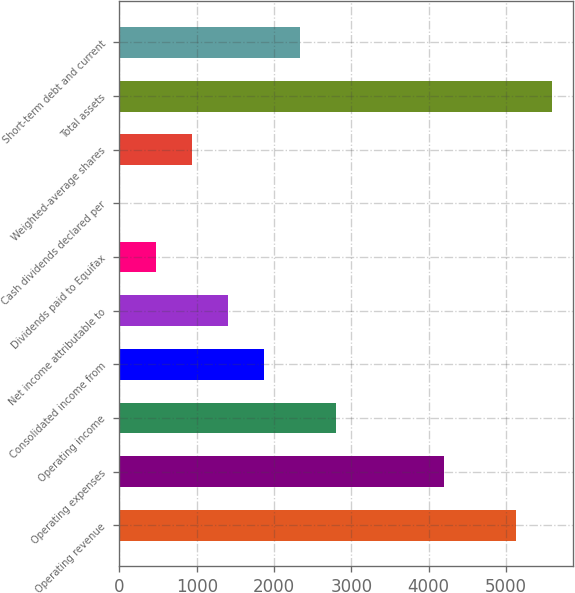Convert chart to OTSL. <chart><loc_0><loc_0><loc_500><loc_500><bar_chart><fcel>Operating revenue<fcel>Operating expenses<fcel>Operating income<fcel>Consolidated income from<fcel>Net income attributable to<fcel>Dividends paid to Equifax<fcel>Cash dividends declared per<fcel>Weighted-average shares<fcel>Total assets<fcel>Short-term debt and current<nl><fcel>5127<fcel>4195<fcel>2797<fcel>1865<fcel>1399<fcel>467<fcel>1<fcel>933<fcel>5593<fcel>2331<nl></chart> 